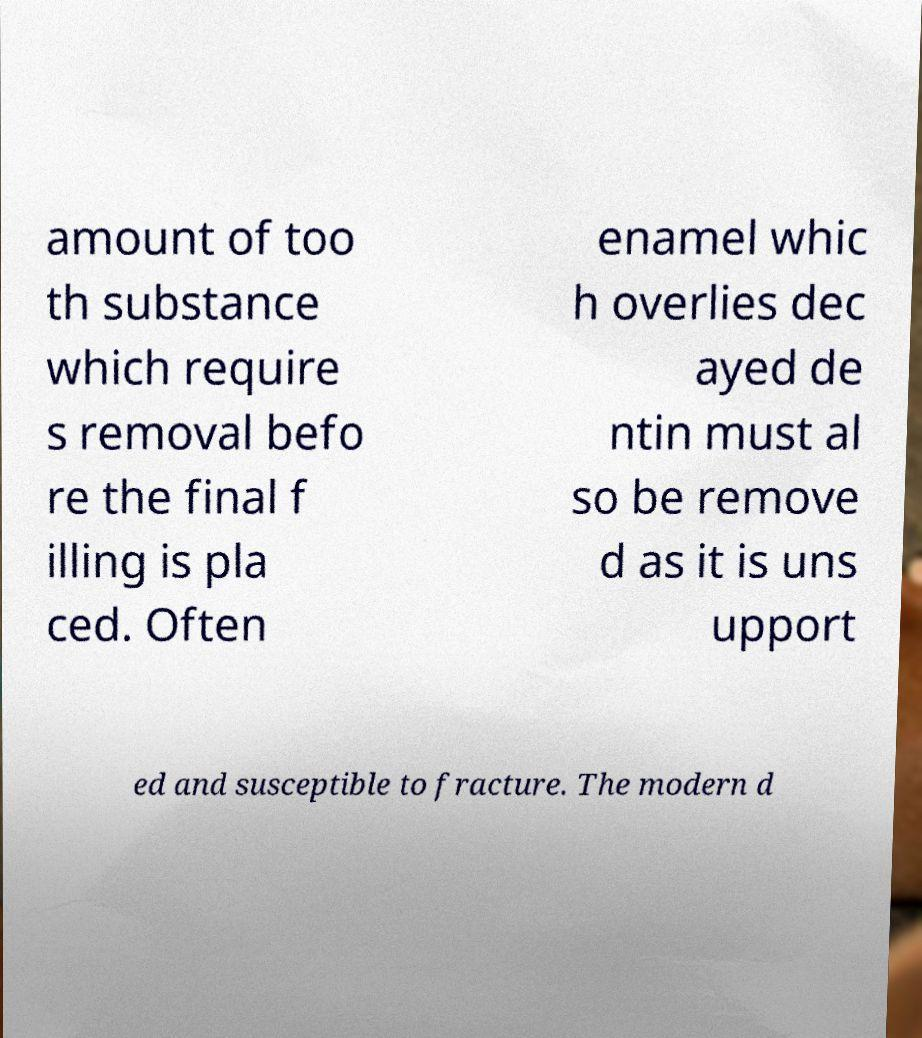Please identify and transcribe the text found in this image. amount of too th substance which require s removal befo re the final f illing is pla ced. Often enamel whic h overlies dec ayed de ntin must al so be remove d as it is uns upport ed and susceptible to fracture. The modern d 